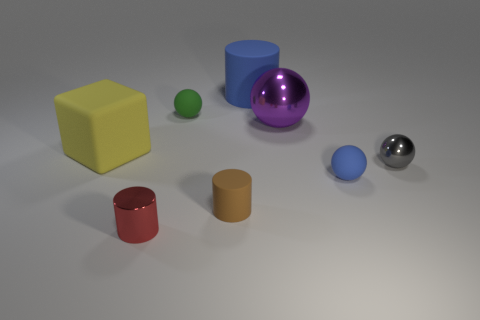Subtract 1 spheres. How many spheres are left? 3 Add 1 big gray shiny balls. How many objects exist? 9 Subtract all cylinders. How many objects are left? 5 Add 2 brown metallic objects. How many brown metallic objects exist? 2 Subtract 1 brown cylinders. How many objects are left? 7 Subtract all tiny cylinders. Subtract all matte cylinders. How many objects are left? 4 Add 7 big objects. How many big objects are left? 10 